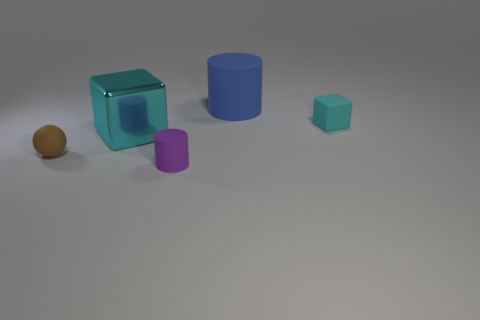What is the color of the rubber cylinder that is the same size as the brown thing?
Offer a very short reply. Purple. Is the large thing that is to the right of the tiny cylinder made of the same material as the brown object?
Offer a terse response. Yes. There is a large thing left of the big thing behind the big cube; is there a big matte thing that is in front of it?
Give a very brief answer. No. There is a small object that is on the right side of the tiny rubber cylinder; is its shape the same as the big matte object?
Your answer should be very brief. No. The small rubber object that is left of the tiny thing that is in front of the small matte ball is what shape?
Your response must be concise. Sphere. What size is the cyan thing that is right of the cube left of the cyan matte block that is behind the ball?
Give a very brief answer. Small. There is another matte thing that is the same shape as the purple object; what color is it?
Keep it short and to the point. Blue. Is the blue cylinder the same size as the purple matte cylinder?
Your answer should be very brief. No. There is a brown thing that is in front of the blue thing; what is its material?
Make the answer very short. Rubber. How many other objects are there of the same shape as the brown matte object?
Give a very brief answer. 0. 